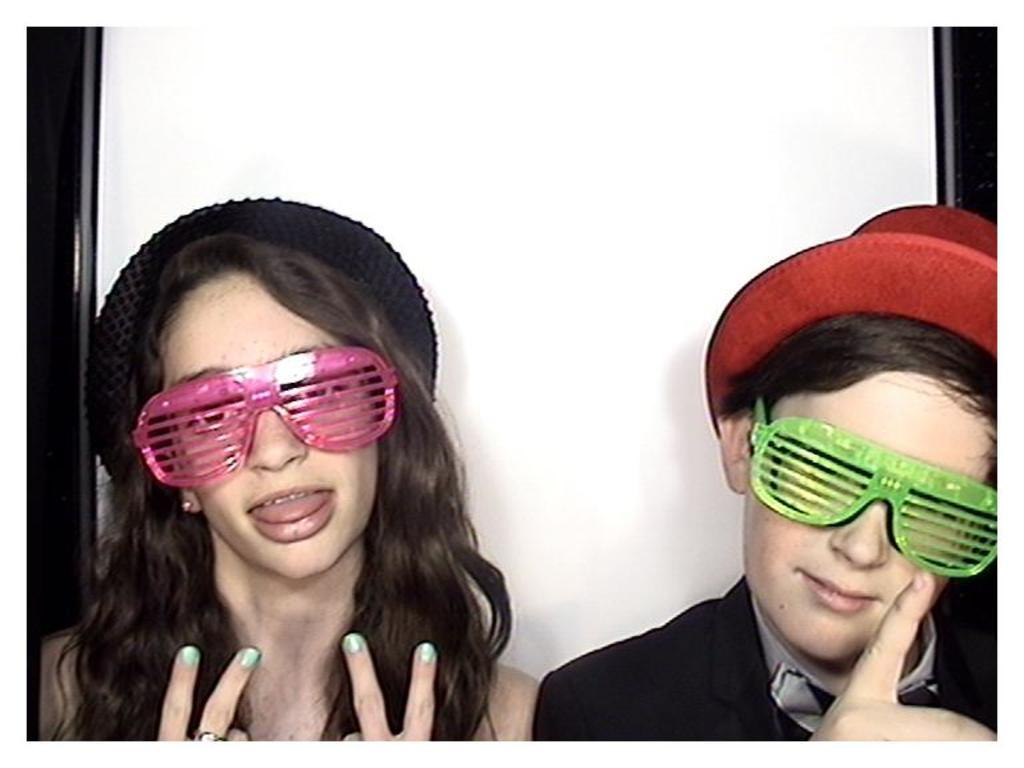How many people are in the image? There are two people in the image. What are the people wearing on their faces? Both people are wearing spectacles. What else are the people wearing on their heads? Both people are wearing caps. What type of hydrant can be seen in the image? There is no hydrant present in the image. How many cherries are being held by the people in the image? There are no cherries present in the image. 